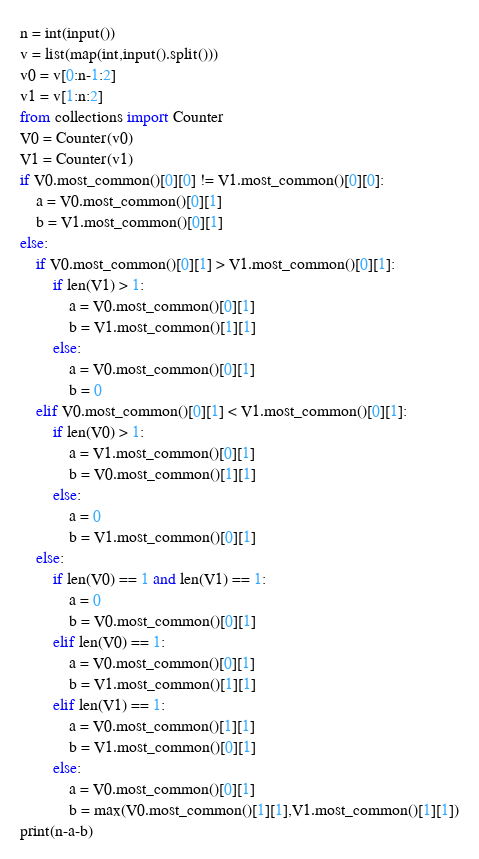<code> <loc_0><loc_0><loc_500><loc_500><_Python_>n = int(input())
v = list(map(int,input().split()))
v0 = v[0:n-1:2]
v1 = v[1:n:2]
from collections import Counter
V0 = Counter(v0)
V1 = Counter(v1)
if V0.most_common()[0][0] != V1.most_common()[0][0]:
    a = V0.most_common()[0][1]
    b = V1.most_common()[0][1]
else:
    if V0.most_common()[0][1] > V1.most_common()[0][1]:
        if len(V1) > 1:
            a = V0.most_common()[0][1]
            b = V1.most_common()[1][1]
        else:
            a = V0.most_common()[0][1]
            b = 0
    elif V0.most_common()[0][1] < V1.most_common()[0][1]:
        if len(V0) > 1:
            a = V1.most_common()[0][1]
            b = V0.most_common()[1][1]
        else:
            a = 0
            b = V1.most_common()[0][1]
    else:
        if len(V0) == 1 and len(V1) == 1:
            a = 0
            b = V0.most_common()[0][1]
        elif len(V0) == 1:
            a = V0.most_common()[0][1]
            b = V1.most_common()[1][1]
        elif len(V1) == 1:
            a = V0.most_common()[1][1]
            b = V1.most_common()[0][1]
        else:
            a = V0.most_common()[0][1]
            b = max(V0.most_common()[1][1],V1.most_common()[1][1])
print(n-a-b)</code> 